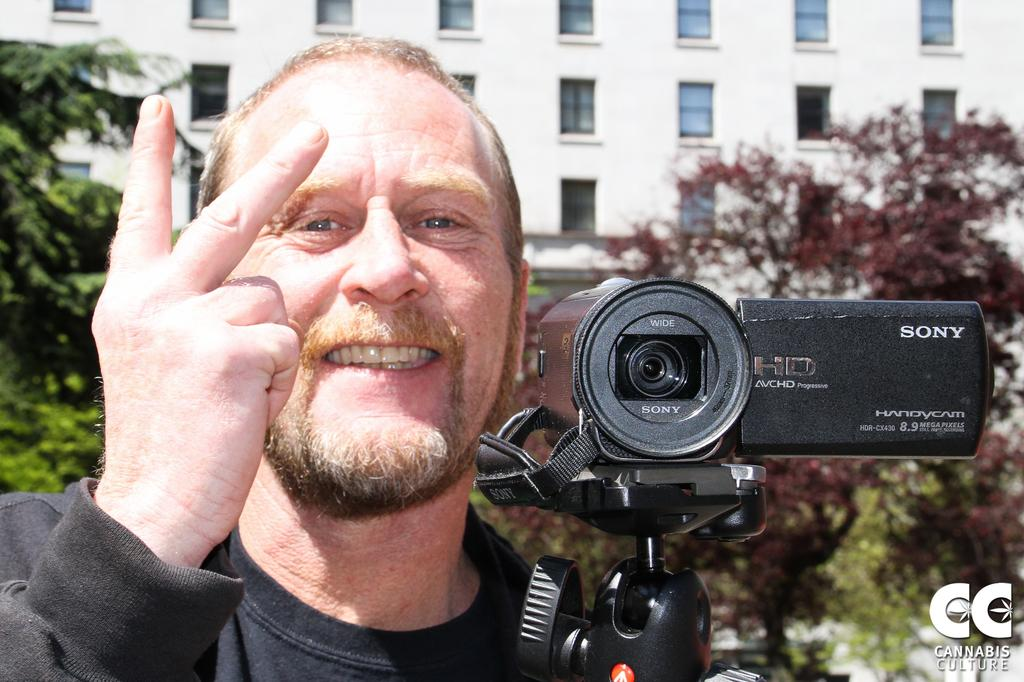Who is the main subject in the image? There is a man in the image. What is the man doing in the image? The man is posing to the camera. What object is the man holding in the image? The man is holding a handycam. What type of sign can be seen in the background of the image? There is no sign visible in the background of the image. What kind of picture is the man taking with the handycam? The image does not provide information about what the man is recording or taking a picture of with the handycam. 